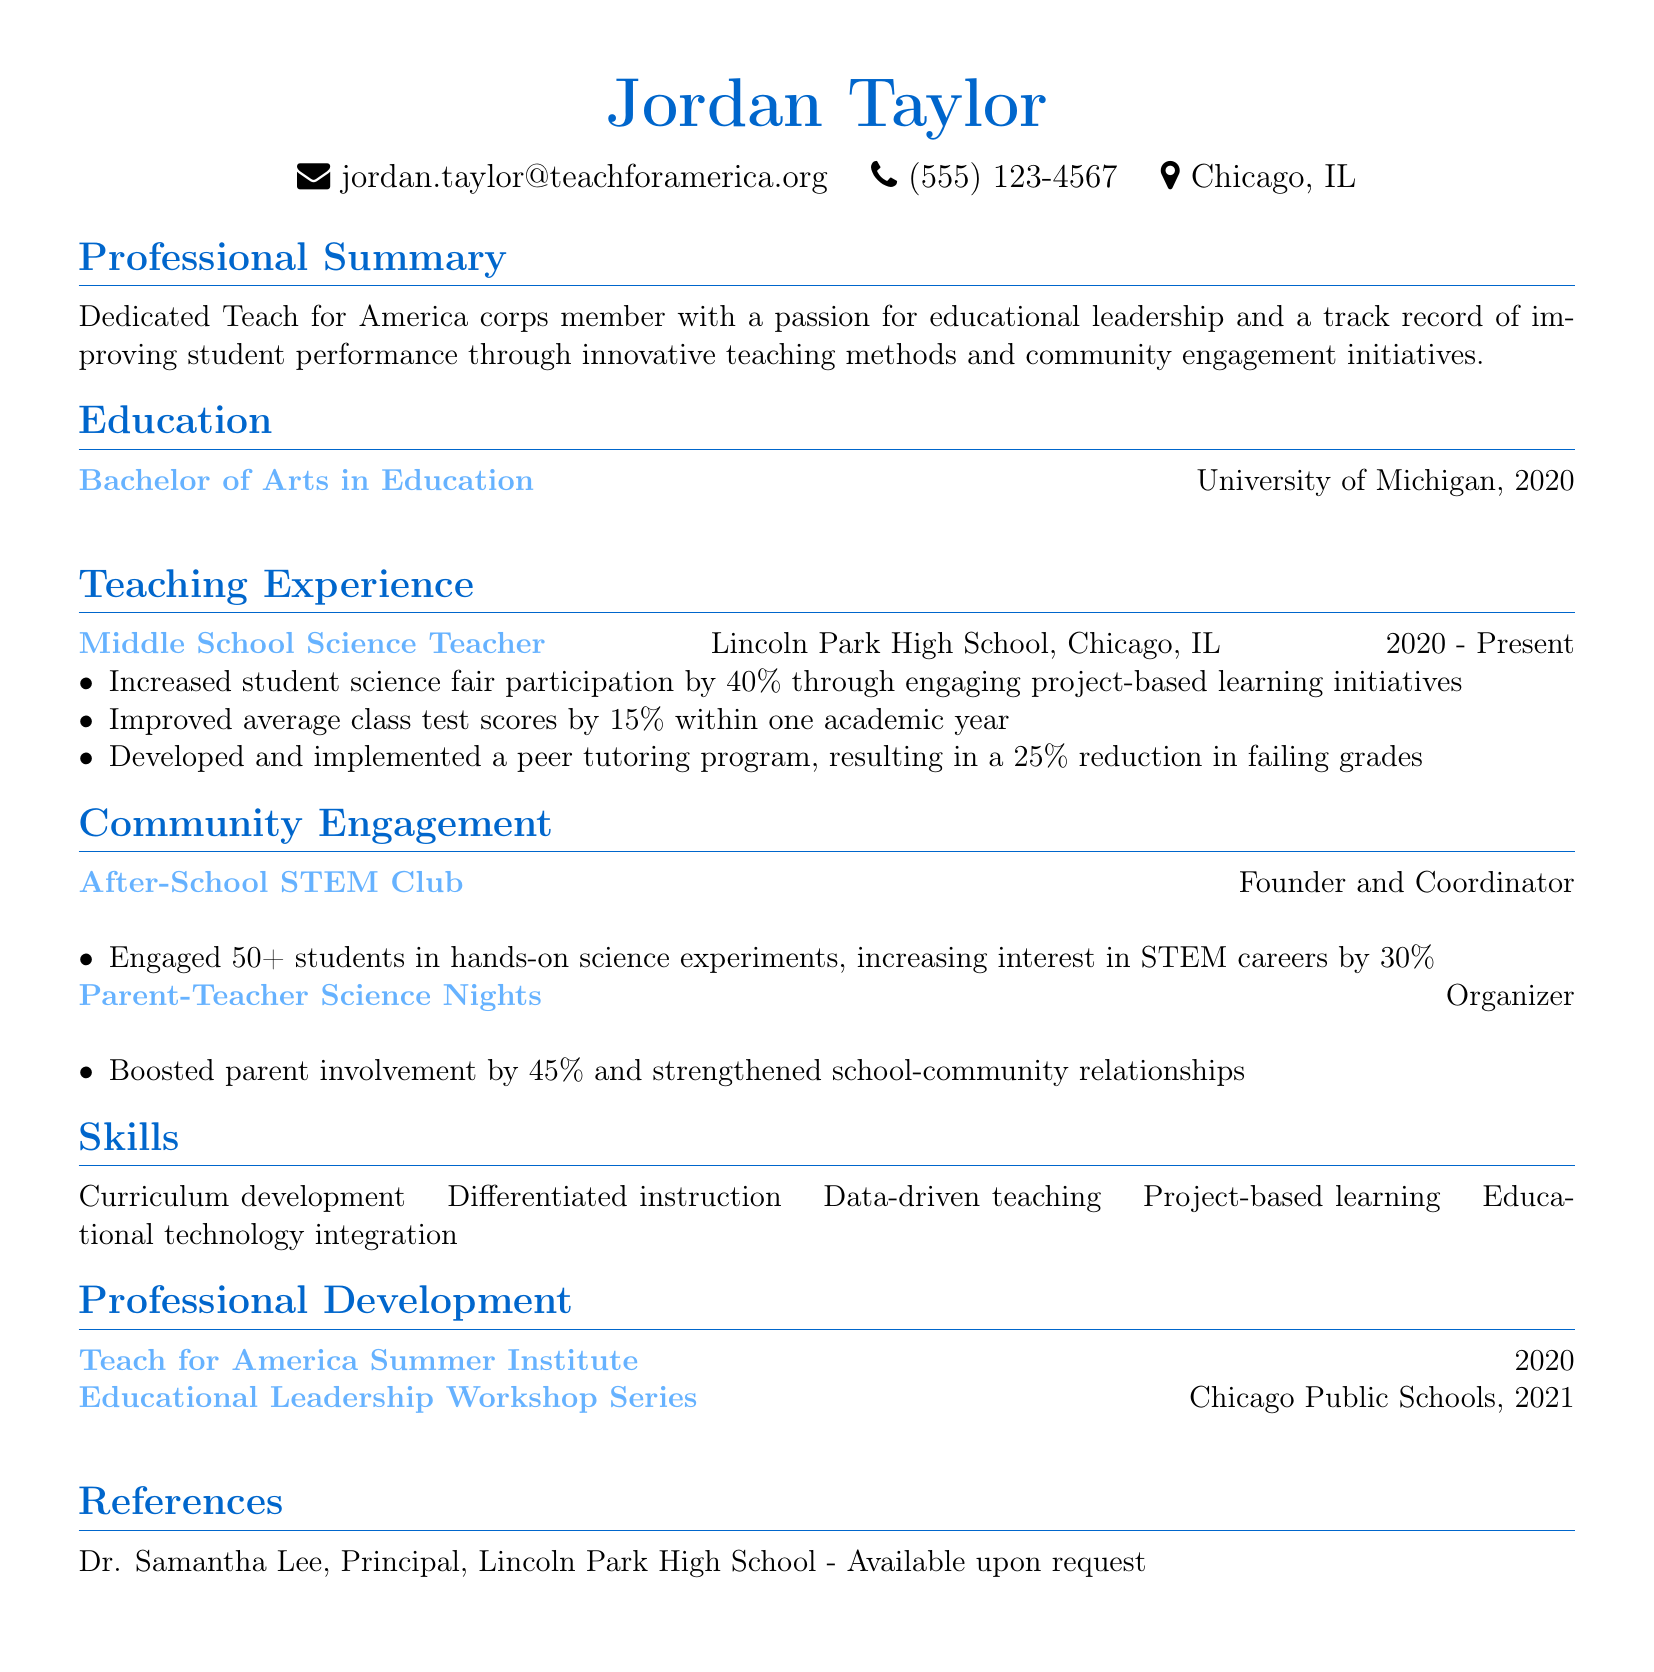What is the name of the individual? The name is stated at the top of the document.
Answer: Jordan Taylor What is the position held by Jordan Taylor? The position is specified in the teaching experience section.
Answer: Middle School Science Teacher During which years has Jordan Taylor been teaching? The duration of teaching experience is provided.
Answer: 2020 - Present What degree did Jordan Taylor earn? The education section lists the degree obtained.
Answer: Bachelor of Arts in Education How much did the average class test scores improve? The improvement percentage is detailed in the teaching achievements.
Answer: 15% What initiative did Jordan Taylor found? The community engagement section lists this initiative.
Answer: After-School STEM Club By what percentage did parent involvement increase during the Parent-Teacher Science Nights? The impact percentage is described in the community engagement section.
Answer: 45% What is one of the skills listed? Skills are enumerated in the skills section of the document.
Answer: Curriculum development What program did Jordan Taylor participate in during the summer of 2020? This detail is found in the professional development section.
Answer: Teach for America Summer Institute 